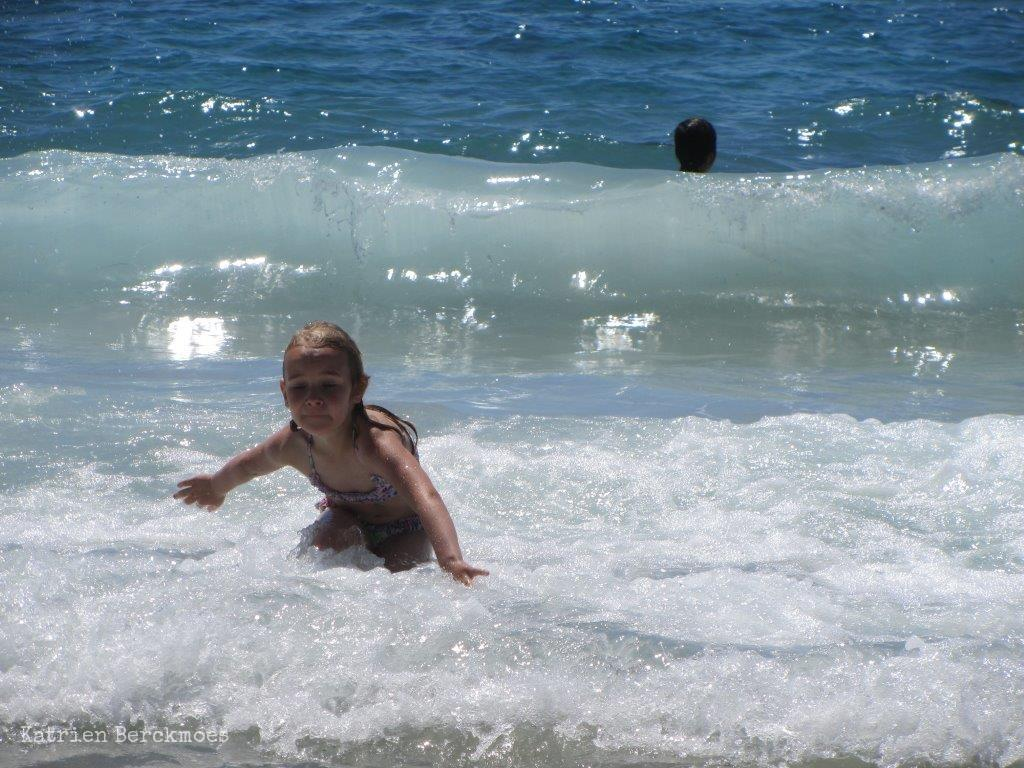Who is present in the image? There are children in the image. What are the children doing in the image? The children are playing in the water. What type of popcorn is being served to the children in the image? There is no popcorn present in the image; the children are playing in the water. What rule is being enforced by the children in the image? There is no mention of a rule being enforced in the image; the children are simply playing in the water. 